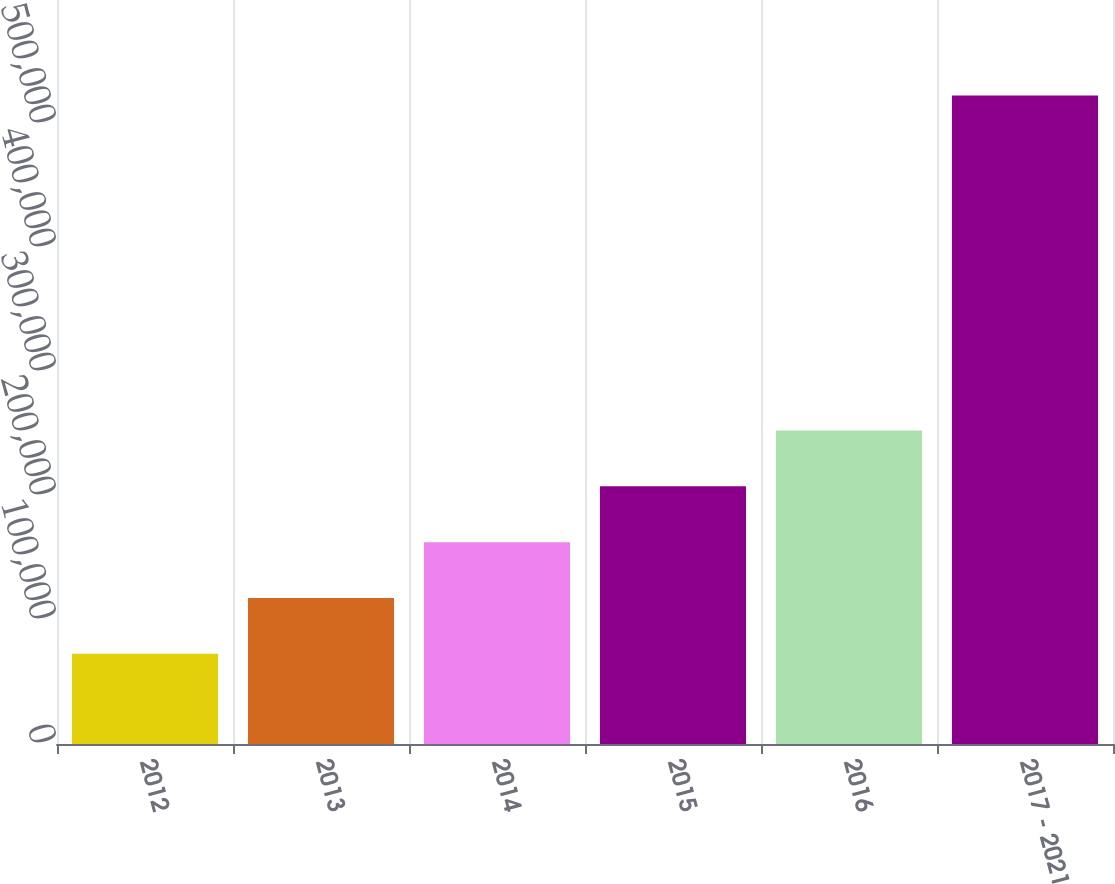Convert chart to OTSL. <chart><loc_0><loc_0><loc_500><loc_500><bar_chart><fcel>2012<fcel>2013<fcel>2014<fcel>2015<fcel>2016<fcel>2017 - 2021<nl><fcel>72685<fcel>117720<fcel>162756<fcel>207792<fcel>252827<fcel>523040<nl></chart> 